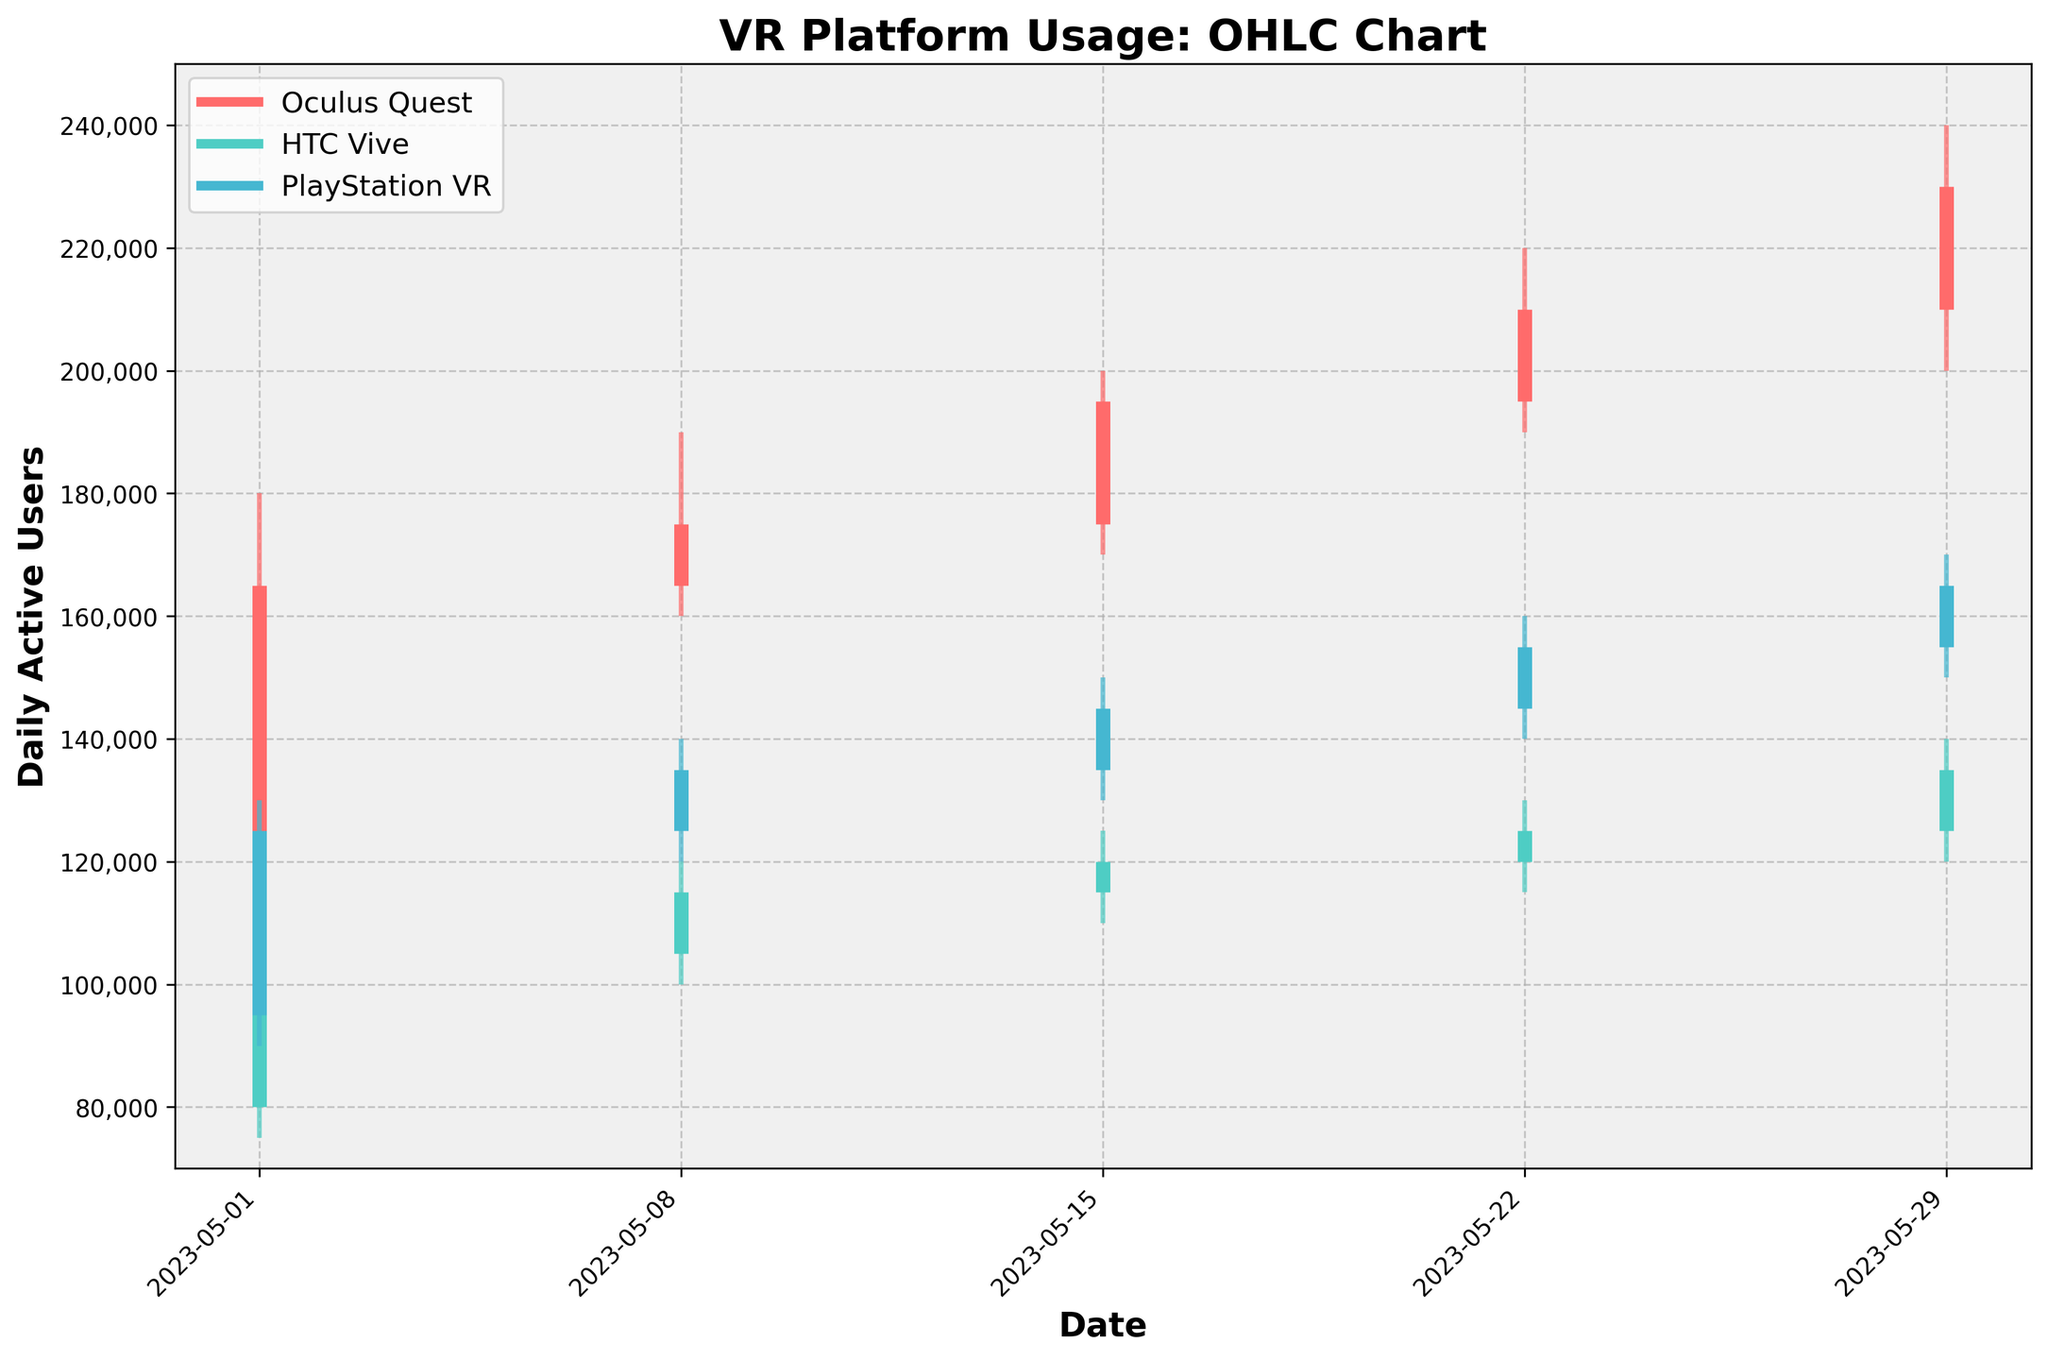What's the title of the figure? The title is located at the top of the figure and should describe the overall content. The title in large, bold text reads "VR Platform Usage: OHLC Chart".
Answer: VR Platform Usage: OHLC Chart What is the color used to represent HTC Vive in the figure? The legend on the figure indicates the colors used for each platform. HTC Vive is represented with a color similar to teal.
Answer: Teal On which date did Oculus Quest have the highest High value? Looking at the vertical lines representing the High values for Oculus Quest across all dates, the highest peak reaches up to 240,000. This occurs on 2023-05-29.
Answer: 2023-05-29 How many platforms are compared in the figure? The legend shows all platforms being compared. There are three lines in the legend, each referring to a different VR platform: Oculus Quest, HTC Vive, and PlayStation VR.
Answer: 3 What's the range of daily active users for PlayStation VR on 2023-05-22? For PlayStation VR on 2023-05-22, the Low value is 140,000 and the High value is 160,000. Subtracting the Low from the High gives the range as 160,000 - 140,000 = 20,000.
Answer: 20,000 Which platform had the least variations in usage over the month? Variations can be gauged by looking at the differences between the High and Low values. HTC Vive has the smallest range in the OHLC chart compared to the others, indicating the least variation.
Answer: HTC Vive What was the difference in Close values for Oculus Quest between 2023-05-22 and 2023-05-29? For Oculus Quest, the Close value on 2023-05-22 was 210,000, and on 2023-05-29, it was 230,000. The difference is 230,000 - 210,000 = 20,000.
Answer: 20,000 Which date saw the lowest Low value for HTC Vive? By examining the Low values of HTC Vive across the dates, the lowest value observed is 75,000 on 2023-05-01.
Answer: 2023-05-01 For PlayStation VR, did the High value ever surpass 150,000? Reviewing the High values for PlayStation VR in the OHLC chart, the values on 2023-05-15, 2023-05-22, and 2023-05-29 exceeded 150,000. Therefore, there were multiple instances.
Answer: Yes Compare the closing user counts for each platform on 2023-05-08. Which platform had the highest? The Close values on 2023-05-08 are: Oculus Quest at 175,000, HTC Vive at 115,000, and PlayStation VR at 135,000. Oculus Quest had the highest closing user count.
Answer: Oculus Quest 